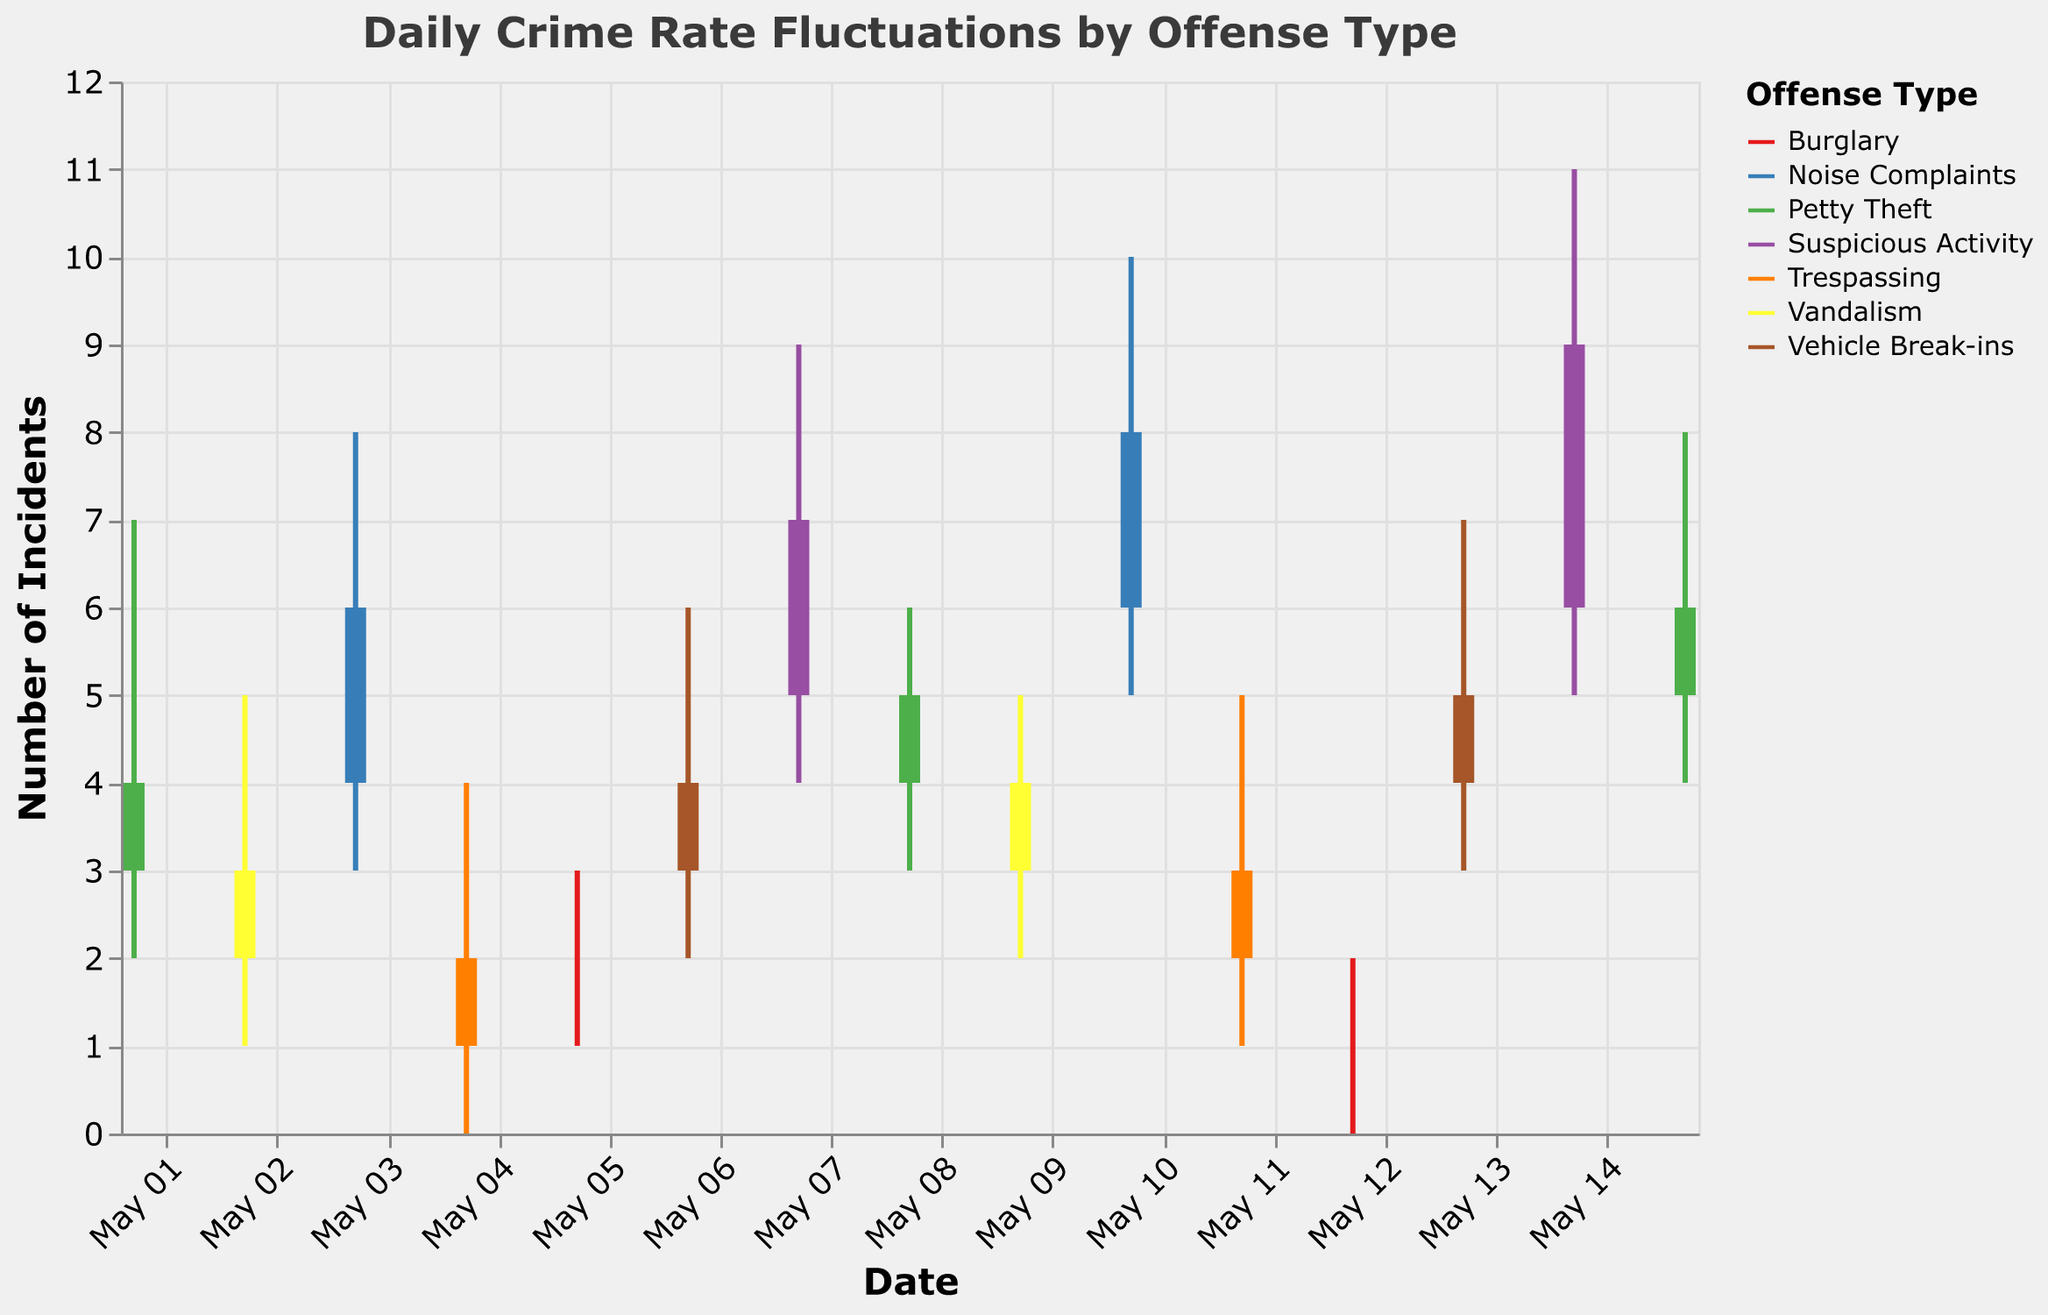What's the title of the figure? The title is typically situated at the top and denotes what the figure represents.
Answer: Daily Crime Rate Fluctuations by Offense Type What does the Y-axis represent? The Y-axis usually labels the type of numerical information provided. In this case, it shows "Number of Incidents" against each date.
Answer: Number of Incidents Which offense type had the highest number of incidents on May 10? The figure visually represents each offense's fluctuations. Here, the highest point on May 10 belongs to Noise Complaints with a high of 10.
Answer: Noise Complaints How did Suspicious Activity change from May 7 to May 14? By comparing the data on these two dates, Suspicious Activity's close value increased from 7 to 9.
Answer: Increased Which date had the lowest number of reported incidents for Burglary? The Burglary data points should be checked across all dates. The lowest low value for Burglary is 0 on May 12.
Answer: May 12 What is the average closing value for Petty Theft over the recorded dates? Calculate the average closing value for Petty Theft. Sum the closing values (4+5+6) and divide by the number of entries for Petty Theft (3).
Answer: 5 Were there any days when no incidents were reported for any offense? Analyze the low values across all days and types to find if a 0 appears. However, there are no dates with 0 across all offenses.
Answer: No Which offense had the largest one-day fluctuation in incidents? Compare the differences between high and low for each offense on every date. Suspicious Activity had the largest fluctuation (11-5=6) on May 14.
Answer: Suspicious Activity Compare the fluctuation patterns of Noise Complaints and Vehicle Break-ins. Which had wider variations? Examine the high to low range for both. Noise Complaints have a notably higher range (8-3=5) compared to Vehicle Break-ins (7-3=4).
Answer: Noise Complaints Looking at Petty Theft on May 1 and May 15, was there an increase, decrease, or stability in the close value? Compare the closing values of Petty Theft on these dates, which shows an increase from 4 on May 1 to 6 on May 15.
Answer: Increase 